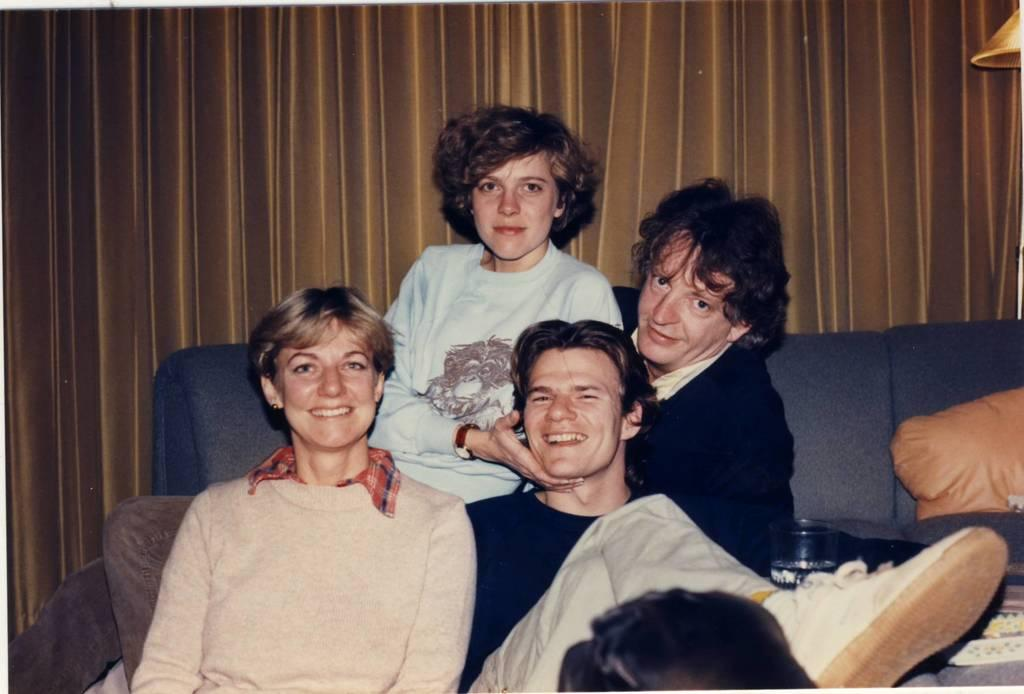How many people are sitting on the sofa in the foreground? There are four persons sitting on a sofa in the foreground. What can be seen on the sofa besides the people? Cushions are present in the foreground. What object is visible in the foreground that might be used for drinking? A glass is visible in the foreground. What type of window treatment can be seen in the background? There are curtains in the background. What type of lighting is present in the background? A lamp is present in the background. What type of room might this image be taken in? The image is likely taken in a hall. What type of minister is sitting on the sofa in the image? There is no minister present in the image; it features four persons sitting on a sofa. Can you see a toad hopping on the sofa in the image? There is no toad present in the image; it features four persons sitting on a sofa. 